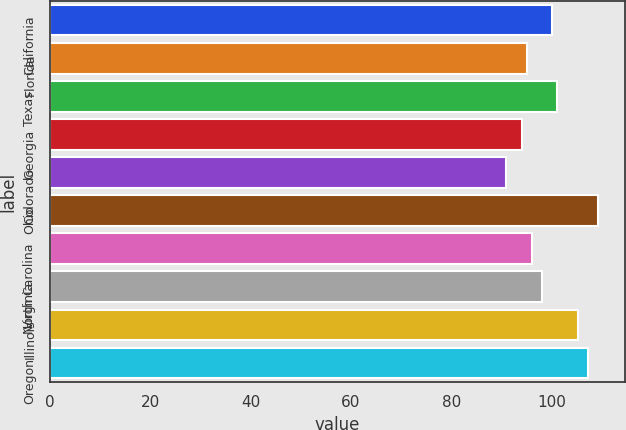Convert chart. <chart><loc_0><loc_0><loc_500><loc_500><bar_chart><fcel>California<fcel>Florida<fcel>Texas<fcel>Georgia<fcel>Colorado<fcel>Ohio<fcel>North Carolina<fcel>Virginia<fcel>Illinois<fcel>Oregon<nl><fcel>100.08<fcel>95.03<fcel>101.09<fcel>94.02<fcel>90.91<fcel>109.17<fcel>96.04<fcel>98.06<fcel>105.13<fcel>107.15<nl></chart> 